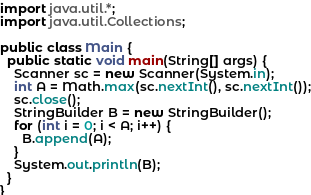<code> <loc_0><loc_0><loc_500><loc_500><_Java_>import java.util.*;
import java.util.Collections;

public class Main {
  public static void main(String[] args) {
    Scanner sc = new Scanner(System.in);
    int A = Math.max(sc.nextInt(), sc.nextInt());
    sc.close();
    StringBuilder B = new StringBuilder();
    for (int i = 0; i < A; i++) {
      B.append(A);
    }
    System.out.println(B);
  }
}
</code> 